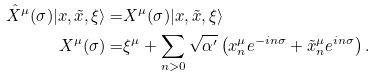<formula> <loc_0><loc_0><loc_500><loc_500>\hat { X } ^ { \mu } ( \sigma ) | x , \tilde { x } , \xi \rangle = & X ^ { \mu } ( \sigma ) | x , \tilde { x } , \xi \rangle \\ X ^ { \mu } ( \sigma ) = & \xi ^ { \mu } + \sum _ { n > 0 } \sqrt { \alpha ^ { \prime } } \left ( x ^ { \mu } _ { n } e ^ { - i n \sigma } + \tilde { x } ^ { \mu } _ { n } e ^ { i n \sigma } \right ) .</formula> 